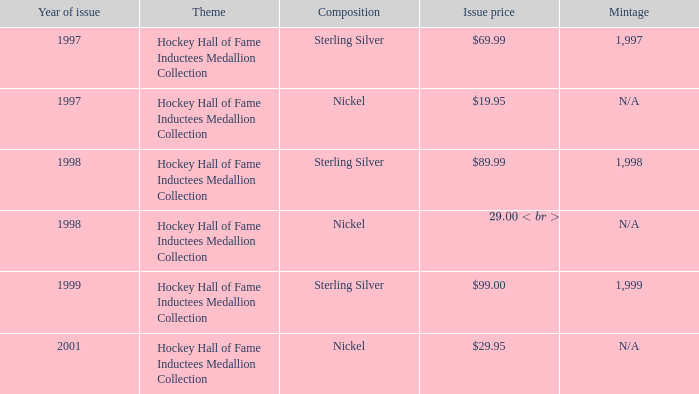Which composition has an issue price of $99.00? Sterling Silver. 